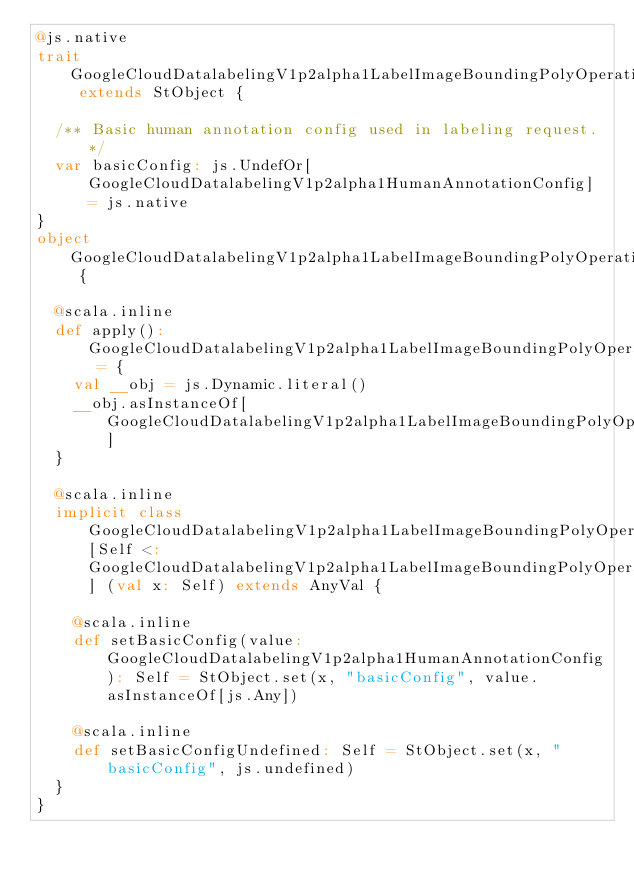<code> <loc_0><loc_0><loc_500><loc_500><_Scala_>@js.native
trait GoogleCloudDatalabelingV1p2alpha1LabelImageBoundingPolyOperationMetadata extends StObject {
  
  /** Basic human annotation config used in labeling request. */
  var basicConfig: js.UndefOr[GoogleCloudDatalabelingV1p2alpha1HumanAnnotationConfig] = js.native
}
object GoogleCloudDatalabelingV1p2alpha1LabelImageBoundingPolyOperationMetadata {
  
  @scala.inline
  def apply(): GoogleCloudDatalabelingV1p2alpha1LabelImageBoundingPolyOperationMetadata = {
    val __obj = js.Dynamic.literal()
    __obj.asInstanceOf[GoogleCloudDatalabelingV1p2alpha1LabelImageBoundingPolyOperationMetadata]
  }
  
  @scala.inline
  implicit class GoogleCloudDatalabelingV1p2alpha1LabelImageBoundingPolyOperationMetadataMutableBuilder[Self <: GoogleCloudDatalabelingV1p2alpha1LabelImageBoundingPolyOperationMetadata] (val x: Self) extends AnyVal {
    
    @scala.inline
    def setBasicConfig(value: GoogleCloudDatalabelingV1p2alpha1HumanAnnotationConfig): Self = StObject.set(x, "basicConfig", value.asInstanceOf[js.Any])
    
    @scala.inline
    def setBasicConfigUndefined: Self = StObject.set(x, "basicConfig", js.undefined)
  }
}
</code> 